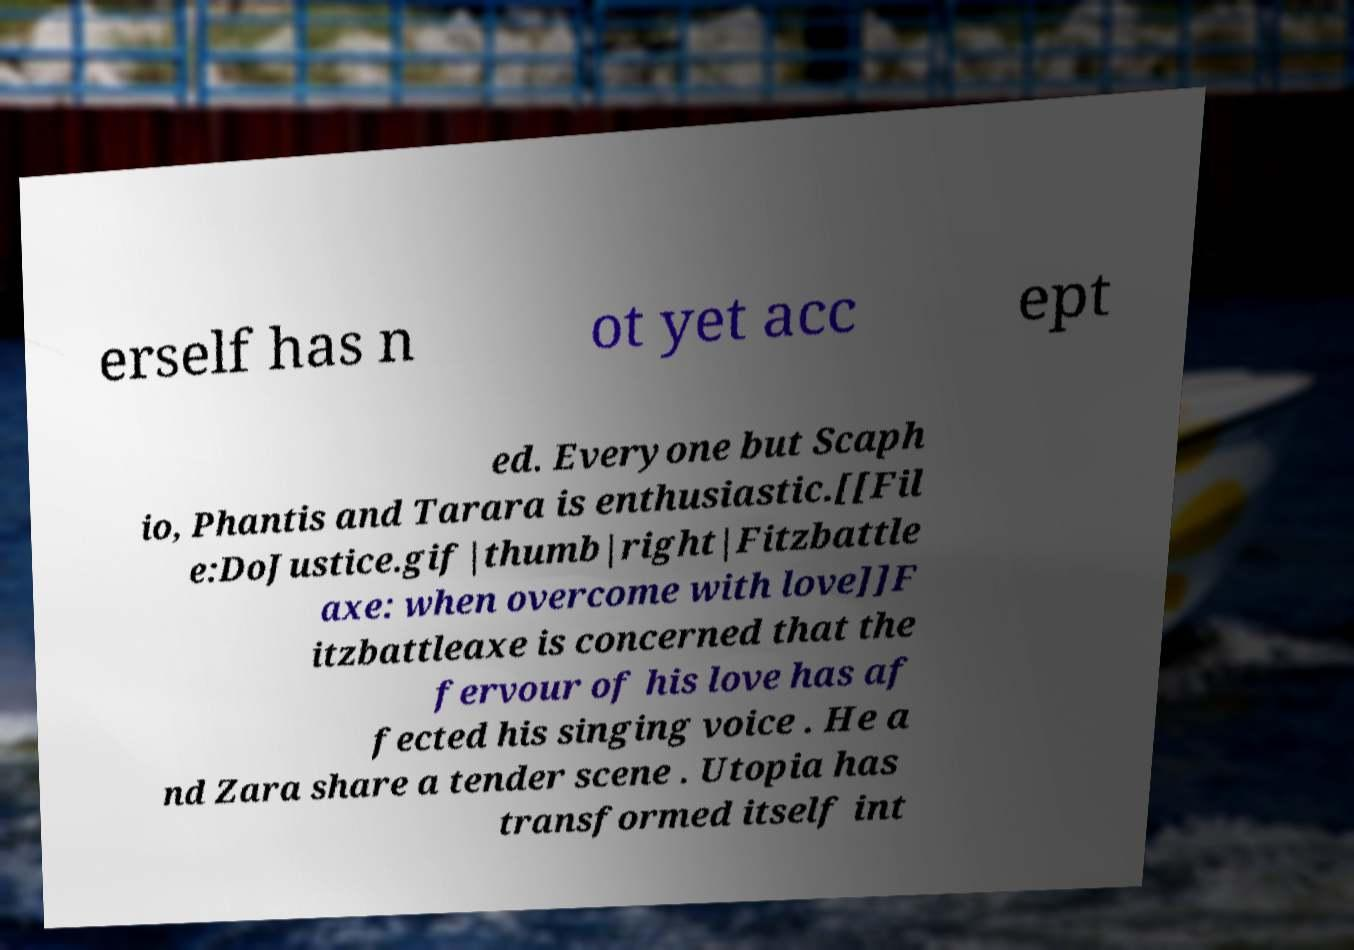There's text embedded in this image that I need extracted. Can you transcribe it verbatim? erself has n ot yet acc ept ed. Everyone but Scaph io, Phantis and Tarara is enthusiastic.[[Fil e:DoJustice.gif|thumb|right|Fitzbattle axe: when overcome with love]]F itzbattleaxe is concerned that the fervour of his love has af fected his singing voice . He a nd Zara share a tender scene . Utopia has transformed itself int 